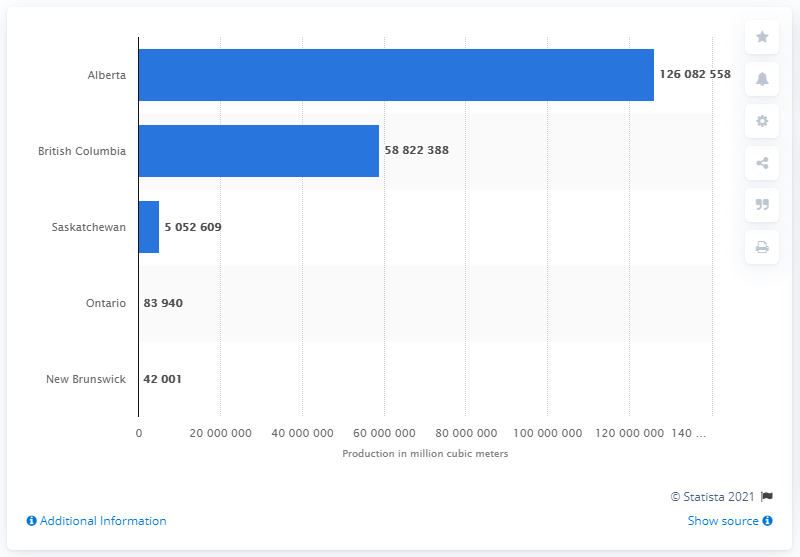Point out several critical features in this image. Alberta is the Canadian province that produces the most natural gas. 